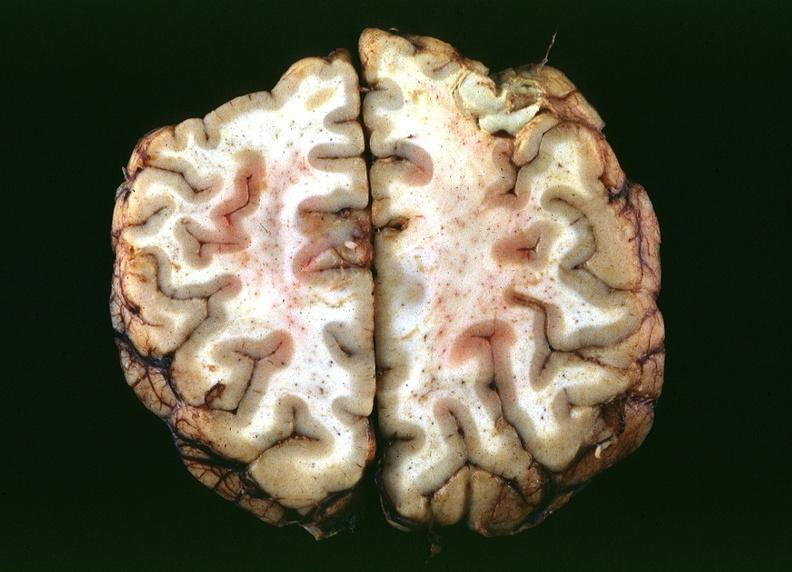does this image show toxoplasmosis, brain?
Answer the question using a single word or phrase. Yes 